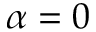Convert formula to latex. <formula><loc_0><loc_0><loc_500><loc_500>\alpha = 0</formula> 